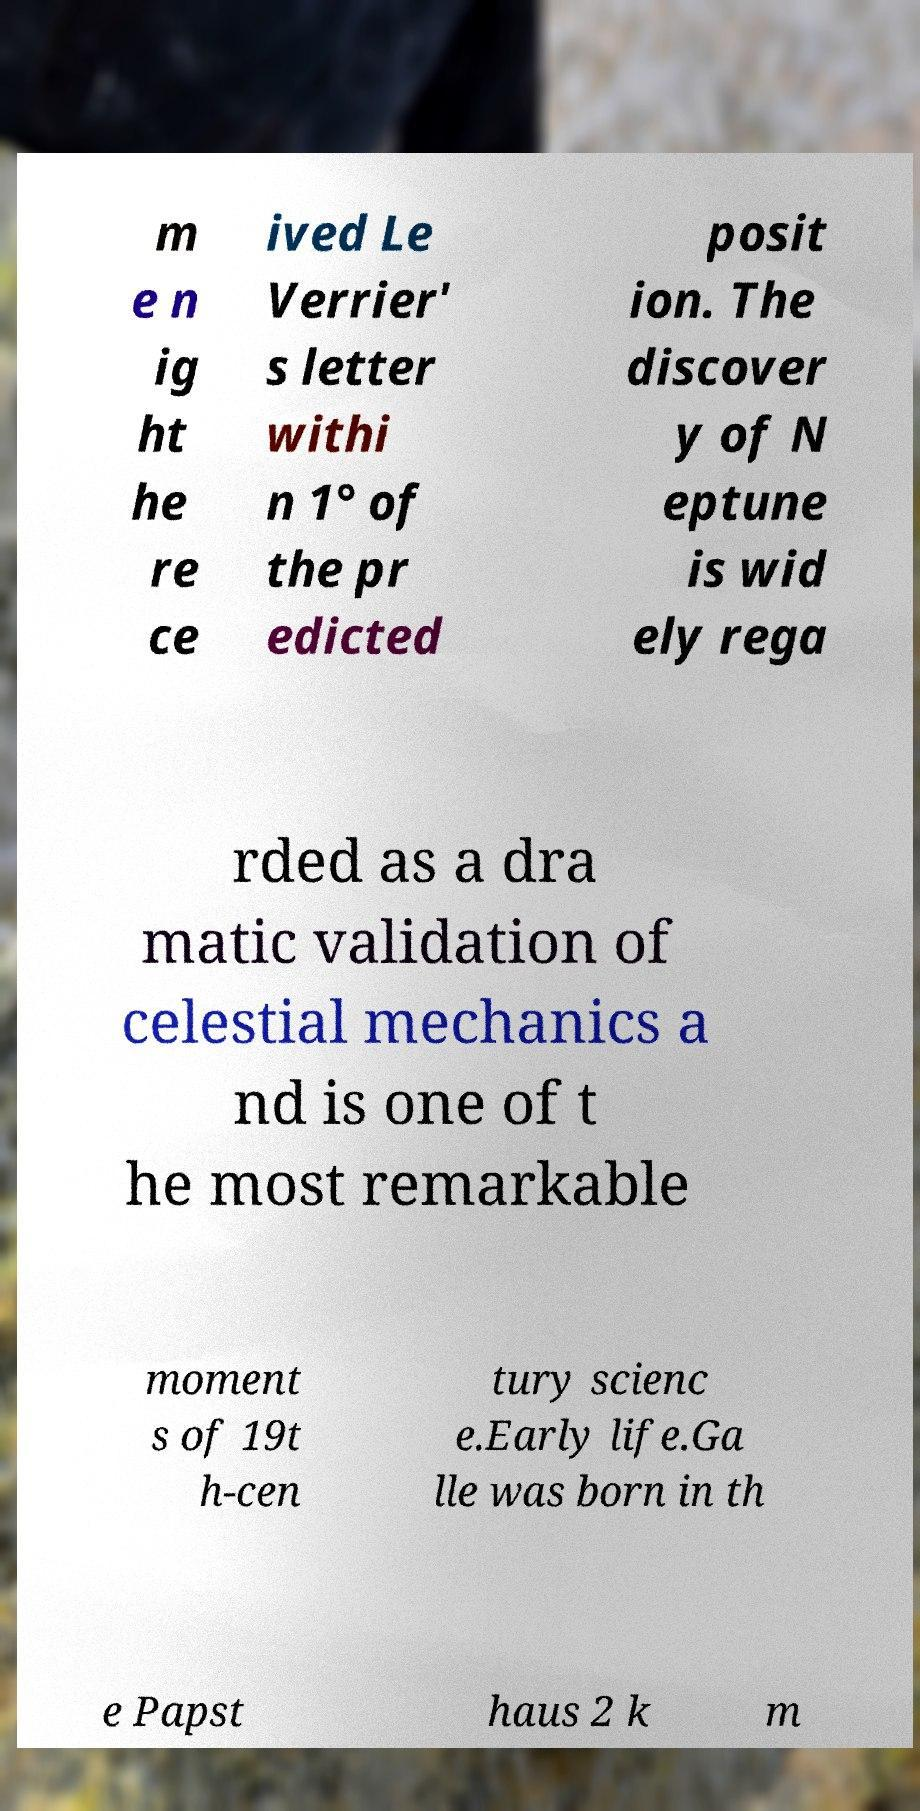Please identify and transcribe the text found in this image. m e n ig ht he re ce ived Le Verrier' s letter withi n 1° of the pr edicted posit ion. The discover y of N eptune is wid ely rega rded as a dra matic validation of celestial mechanics a nd is one of t he most remarkable moment s of 19t h-cen tury scienc e.Early life.Ga lle was born in th e Papst haus 2 k m 